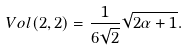Convert formula to latex. <formula><loc_0><loc_0><loc_500><loc_500>V o l ( 2 , 2 ) = \frac { 1 } { 6 \sqrt { 2 } } \sqrt { 2 \alpha + 1 } .</formula> 